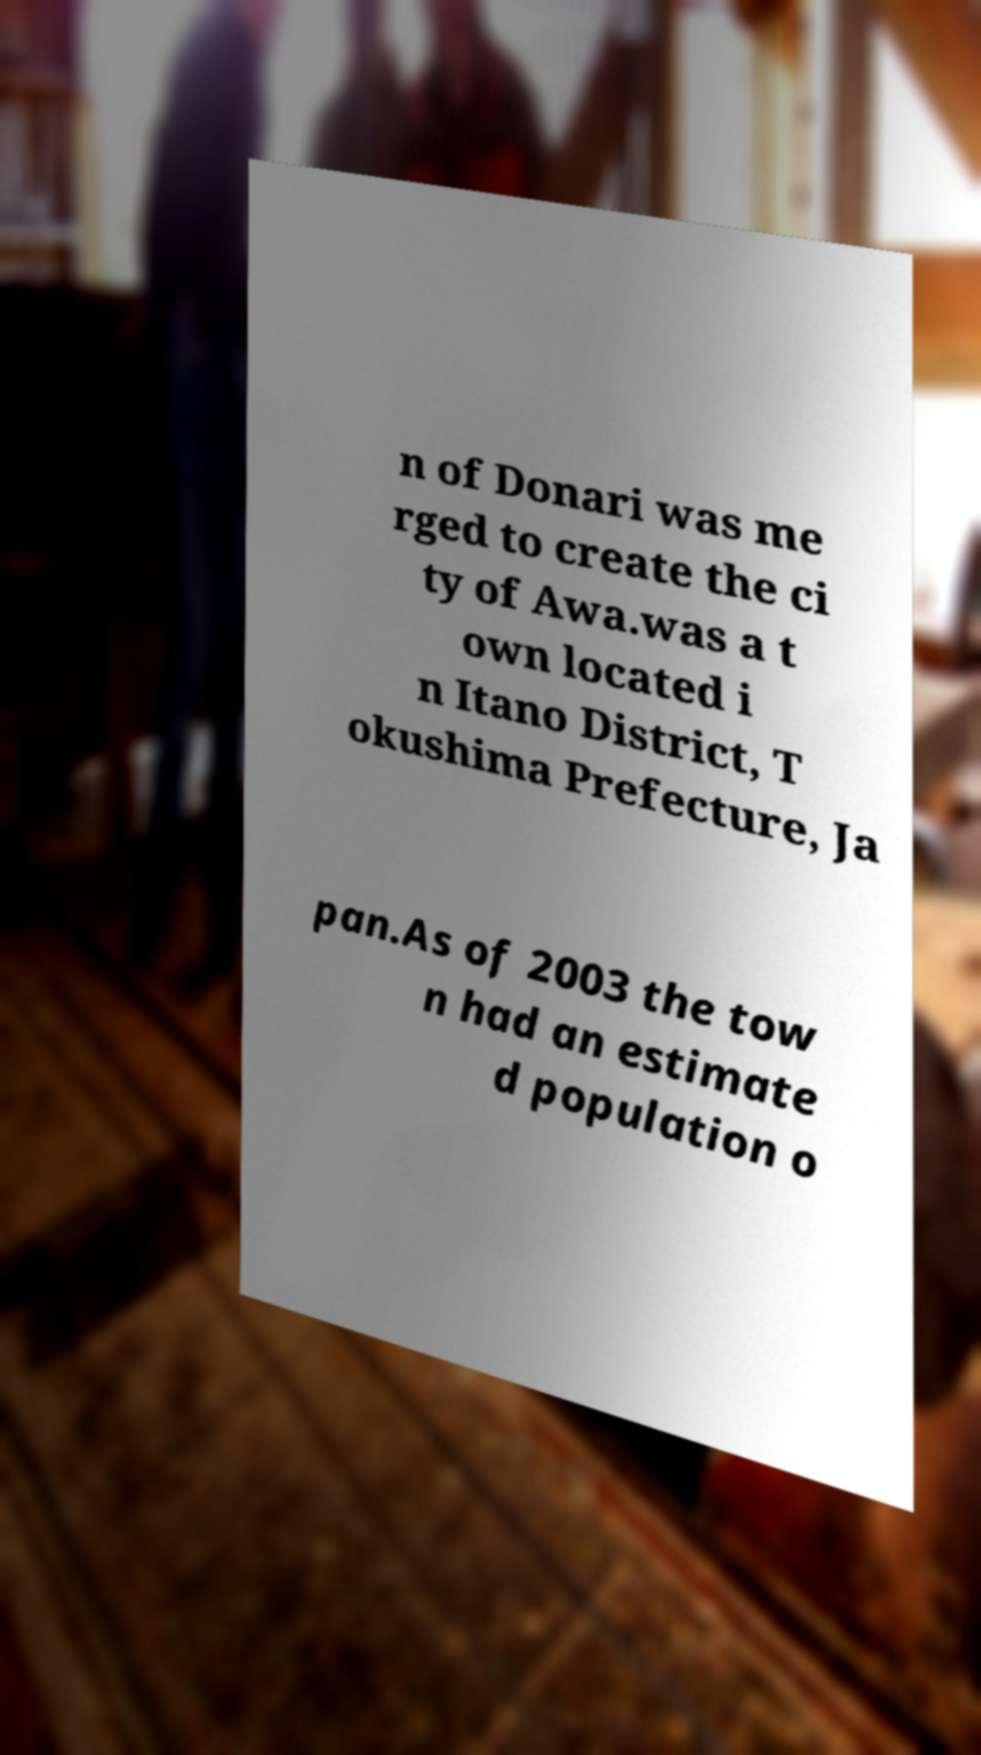There's text embedded in this image that I need extracted. Can you transcribe it verbatim? n of Donari was me rged to create the ci ty of Awa.was a t own located i n Itano District, T okushima Prefecture, Ja pan.As of 2003 the tow n had an estimate d population o 